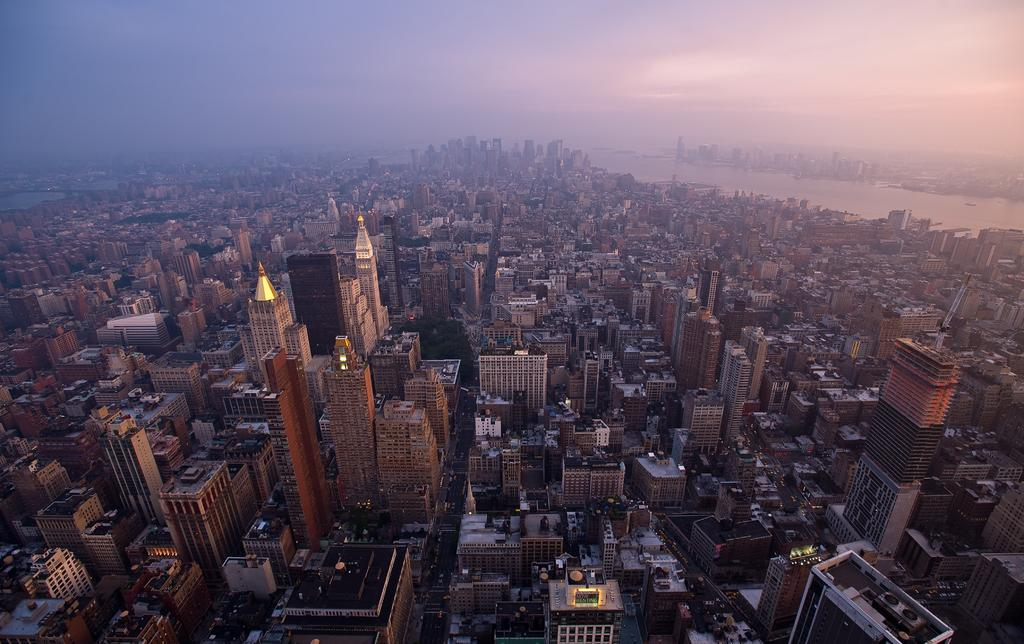What type of structures can be seen in the image? There are buildings in the image. What natural element is visible in the background of the image? There is water visible in the background of the image. What colors are present in the sky in the image? The sky is blue and white in color. What is the cause of the gold rush in the image? There is no gold rush or mention of gold in the image; it features buildings and a blue and white sky. 